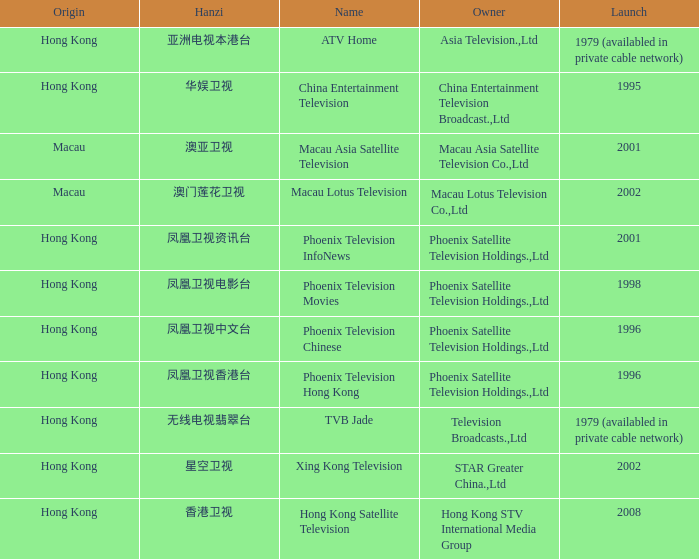Which company launched in 1996 and has a Hanzi of 凤凰卫视中文台? Phoenix Television Chinese. Parse the table in full. {'header': ['Origin', 'Hanzi', 'Name', 'Owner', 'Launch'], 'rows': [['Hong Kong', '亚洲电视本港台', 'ATV Home', 'Asia Television.,Ltd', '1979 (availabled in private cable network)'], ['Hong Kong', '华娱卫视', 'China Entertainment Television', 'China Entertainment Television Broadcast.,Ltd', '1995'], ['Macau', '澳亚卫视', 'Macau Asia Satellite Television', 'Macau Asia Satellite Television Co.,Ltd', '2001'], ['Macau', '澳门莲花卫视', 'Macau Lotus Television', 'Macau Lotus Television Co.,Ltd', '2002'], ['Hong Kong', '凤凰卫视资讯台', 'Phoenix Television InfoNews', 'Phoenix Satellite Television Holdings.,Ltd', '2001'], ['Hong Kong', '凤凰卫视电影台', 'Phoenix Television Movies', 'Phoenix Satellite Television Holdings.,Ltd', '1998'], ['Hong Kong', '凤凰卫视中文台', 'Phoenix Television Chinese', 'Phoenix Satellite Television Holdings.,Ltd', '1996'], ['Hong Kong', '凤凰卫视香港台', 'Phoenix Television Hong Kong', 'Phoenix Satellite Television Holdings.,Ltd', '1996'], ['Hong Kong', '无线电视翡翠台', 'TVB Jade', 'Television Broadcasts.,Ltd', '1979 (availabled in private cable network)'], ['Hong Kong', '星空卫视', 'Xing Kong Television', 'STAR Greater China.,Ltd', '2002'], ['Hong Kong', '香港卫视', 'Hong Kong Satellite Television', 'Hong Kong STV International Media Group', '2008']]} 